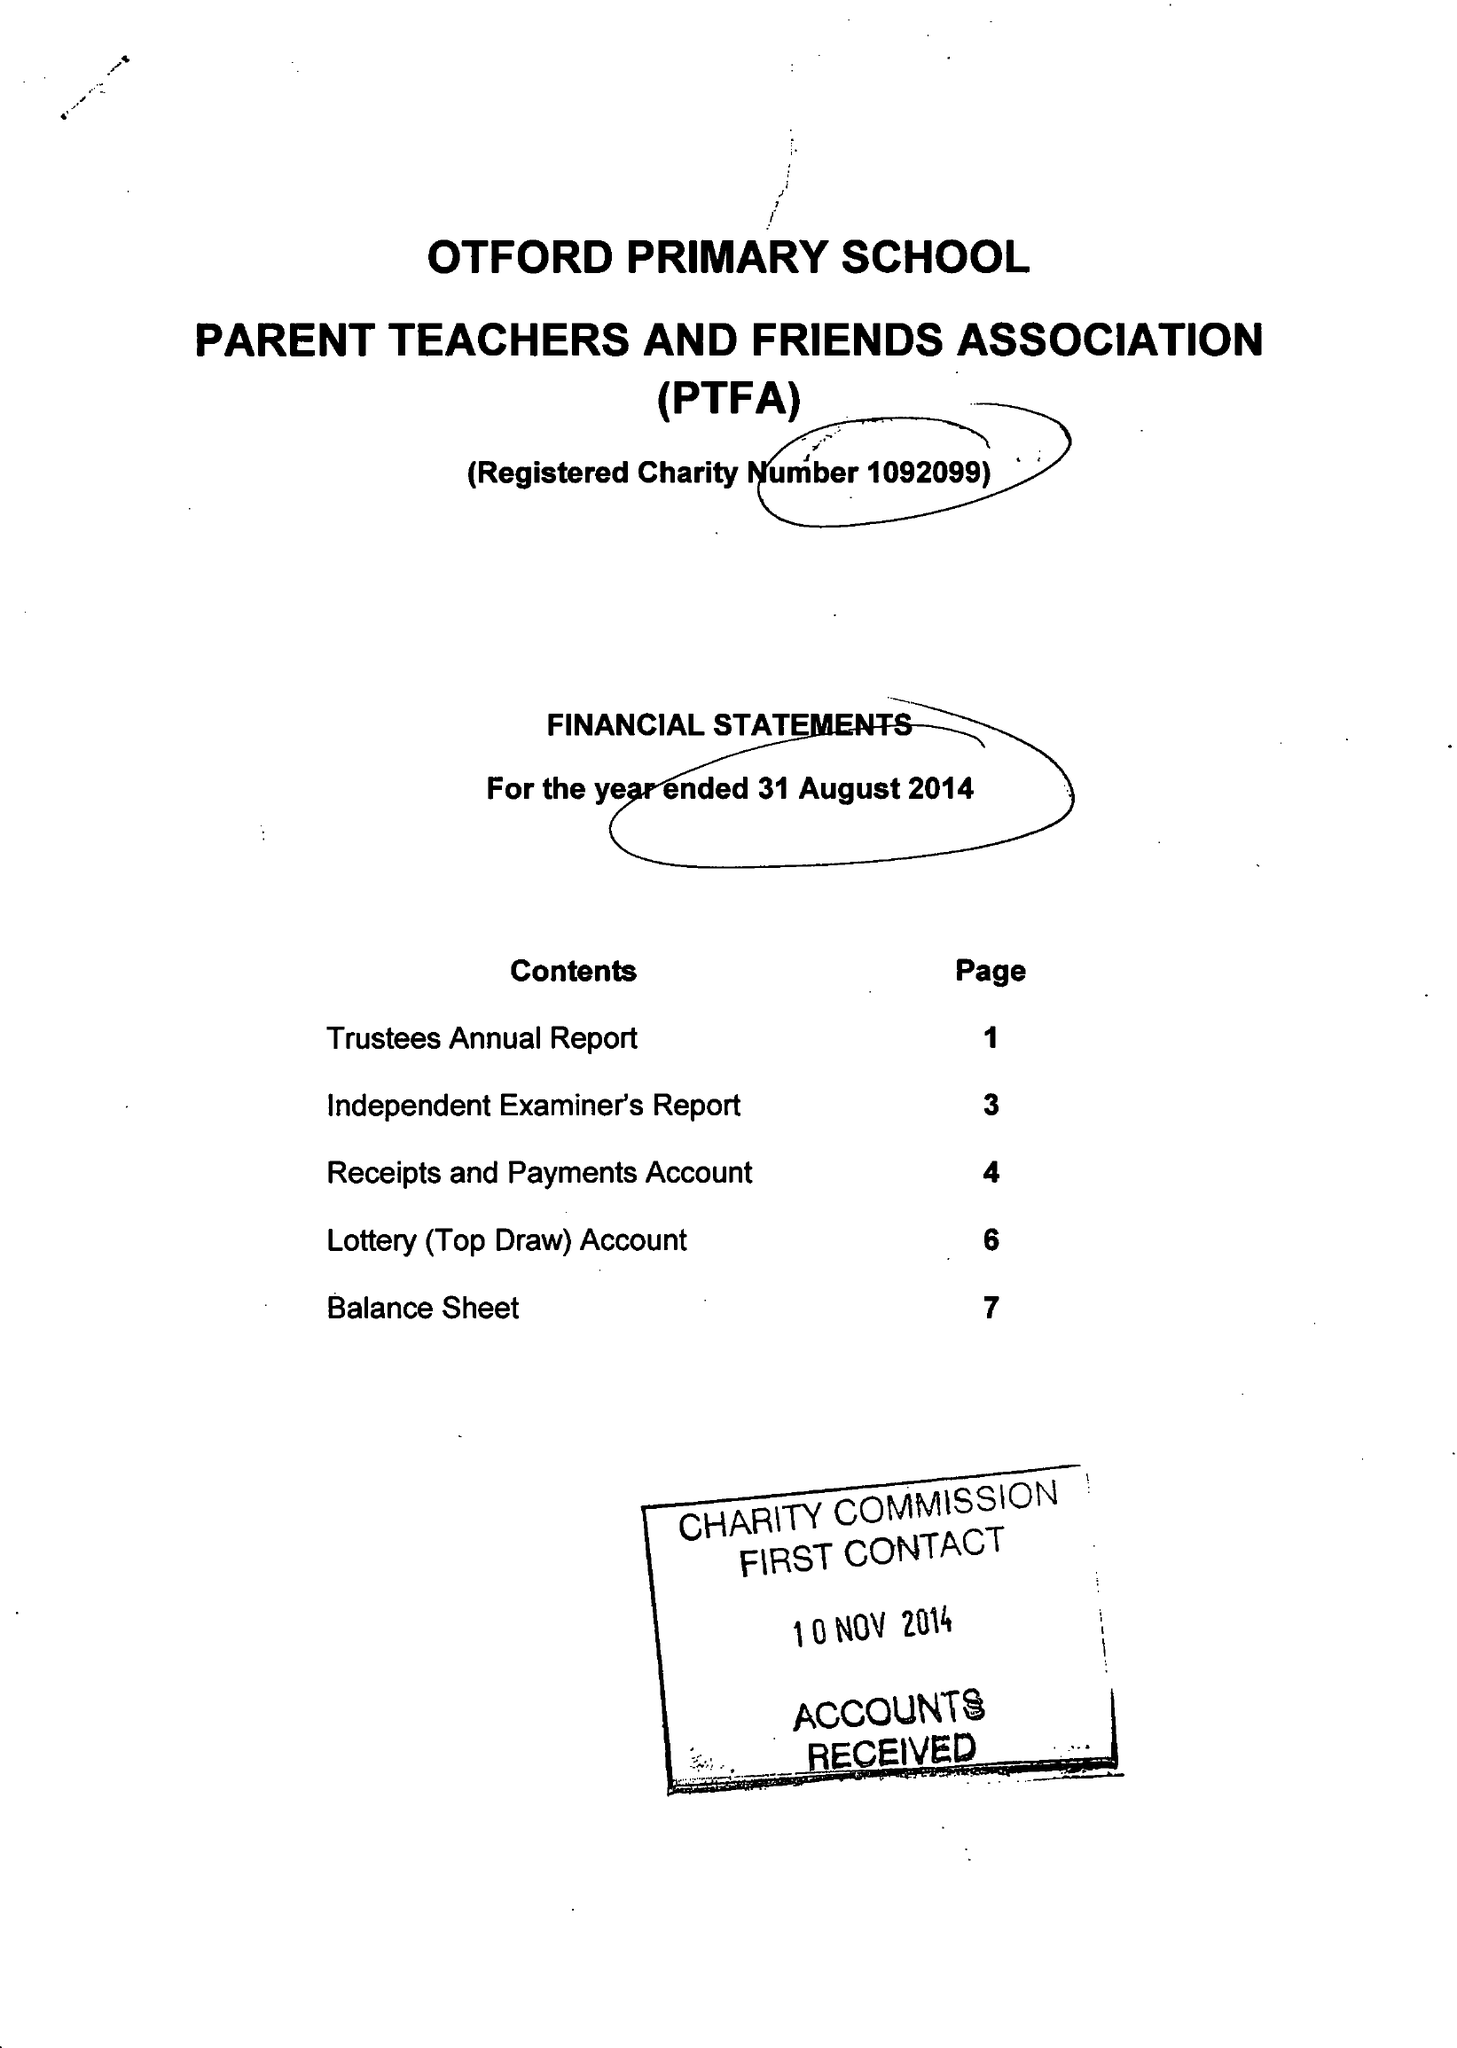What is the value for the income_annually_in_british_pounds?
Answer the question using a single word or phrase. 25975.00 